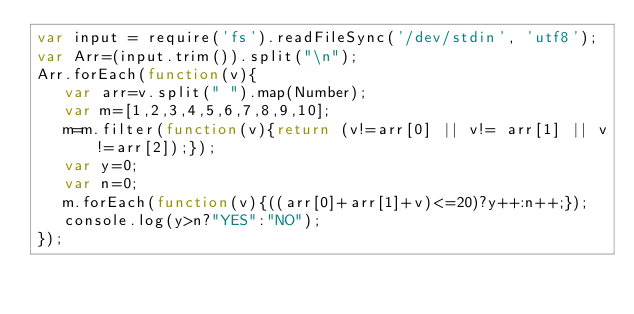<code> <loc_0><loc_0><loc_500><loc_500><_JavaScript_>var input = require('fs').readFileSync('/dev/stdin', 'utf8');
var Arr=(input.trim()).split("\n");
Arr.forEach(function(v){
   var arr=v.split(" ").map(Number);
   var m=[1,2,3,4,5,6,7,8,9,10];
   m=m.filter(function(v){return (v!=arr[0] || v!= arr[1] || v!=arr[2]);});
   var y=0;
   var n=0;
   m.forEach(function(v){((arr[0]+arr[1]+v)<=20)?y++:n++;});
   console.log(y>n?"YES":"NO");
});</code> 